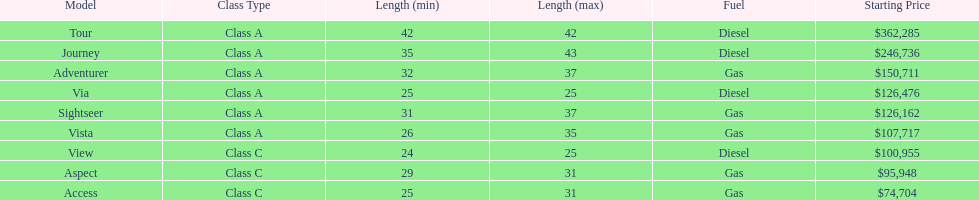What is the price of bot the via and tour models combined? $488,761. Would you mind parsing the complete table? {'header': ['Model', 'Class Type', 'Length (min)', 'Length (max)', 'Fuel', 'Starting Price'], 'rows': [['Tour', 'Class A', '42', '42', 'Diesel', '$362,285'], ['Journey', 'Class A', '35', '43', 'Diesel', '$246,736'], ['Adventurer', 'Class A', '32', '37', 'Gas', '$150,711'], ['Via', 'Class A', '25', '25', 'Diesel', '$126,476'], ['Sightseer', 'Class A', '31', '37', 'Gas', '$126,162'], ['Vista', 'Class A', '26', '35', 'Gas', '$107,717'], ['View', 'Class C', '24', '25', 'Diesel', '$100,955'], ['Aspect', 'Class C', '29', '31', 'Gas', '$95,948'], ['Access', 'Class C', '25', '31', 'Gas', '$74,704']]} 